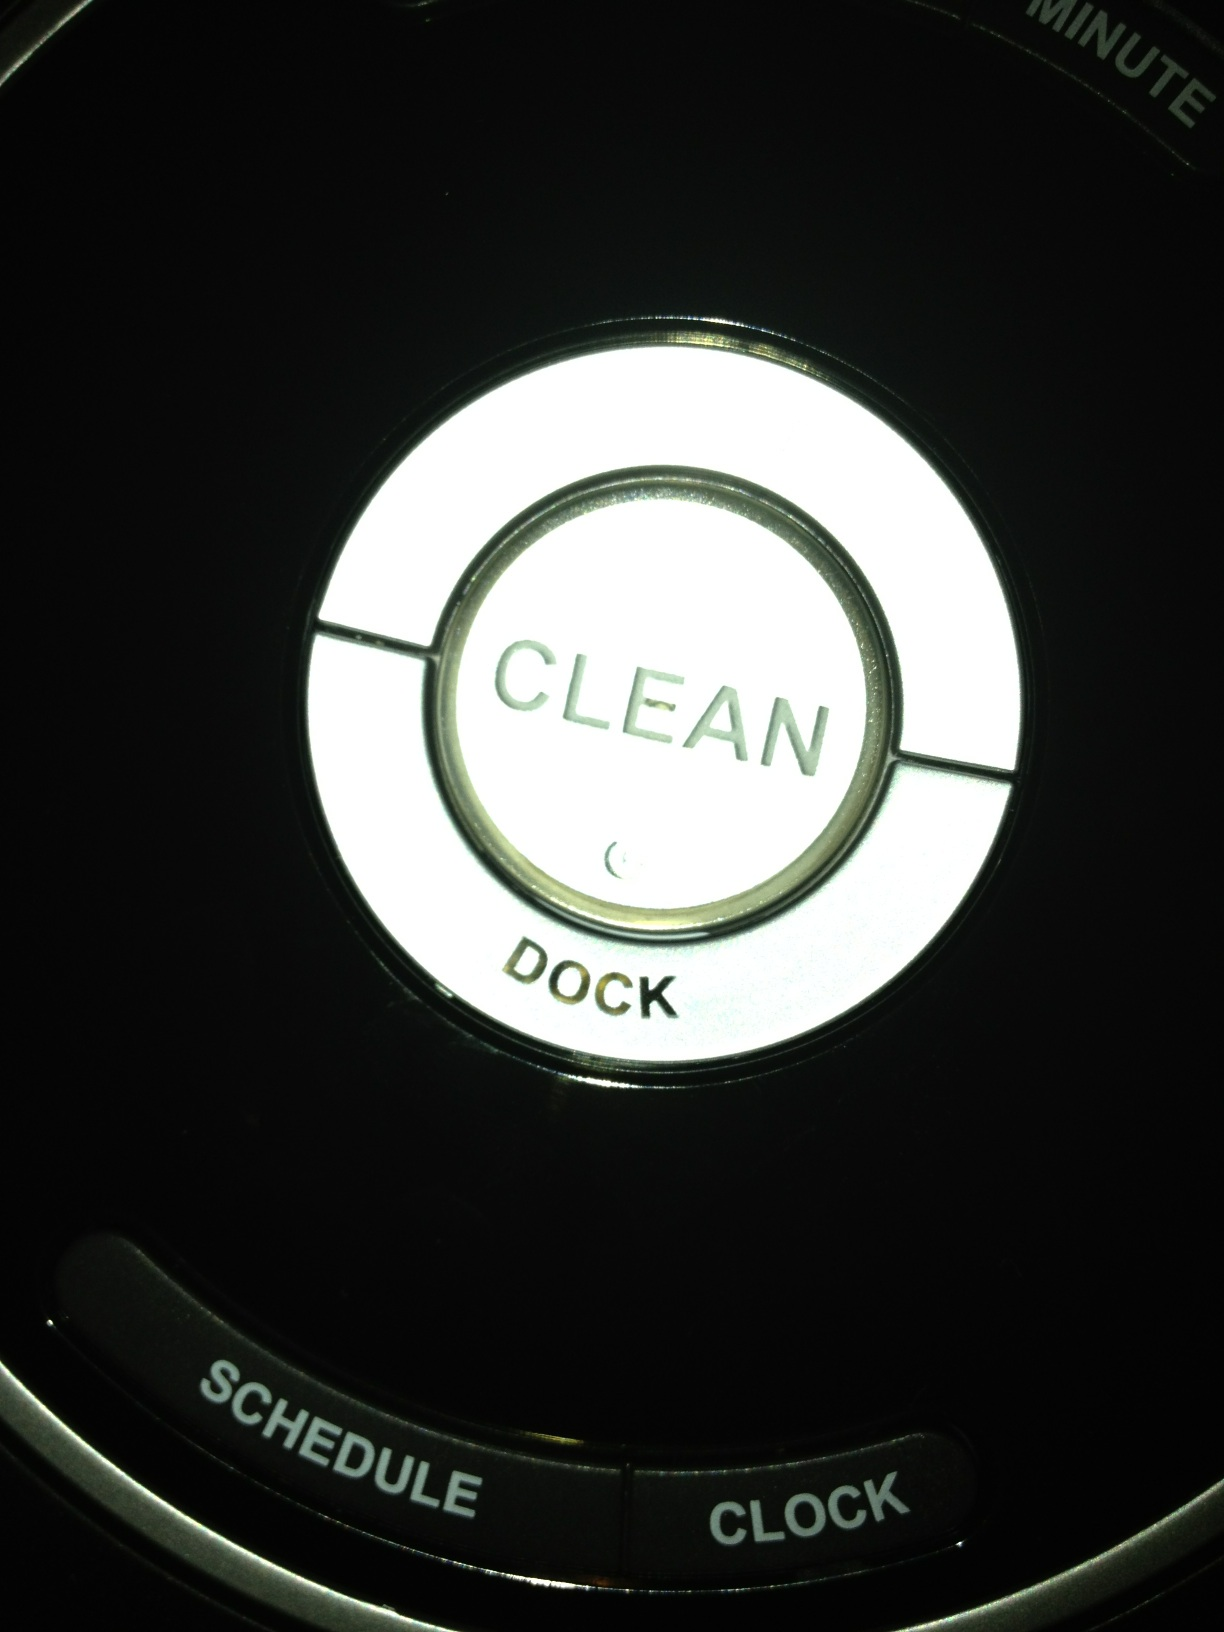How would you explain the purpose of the middle button and its associated label? The middle button in the image is labeled 'SCHEDULE'. Its primary function is likely to schedule cleaning sessions in advance, possibly allowing the user to program daily or weekly cleaning routines. 